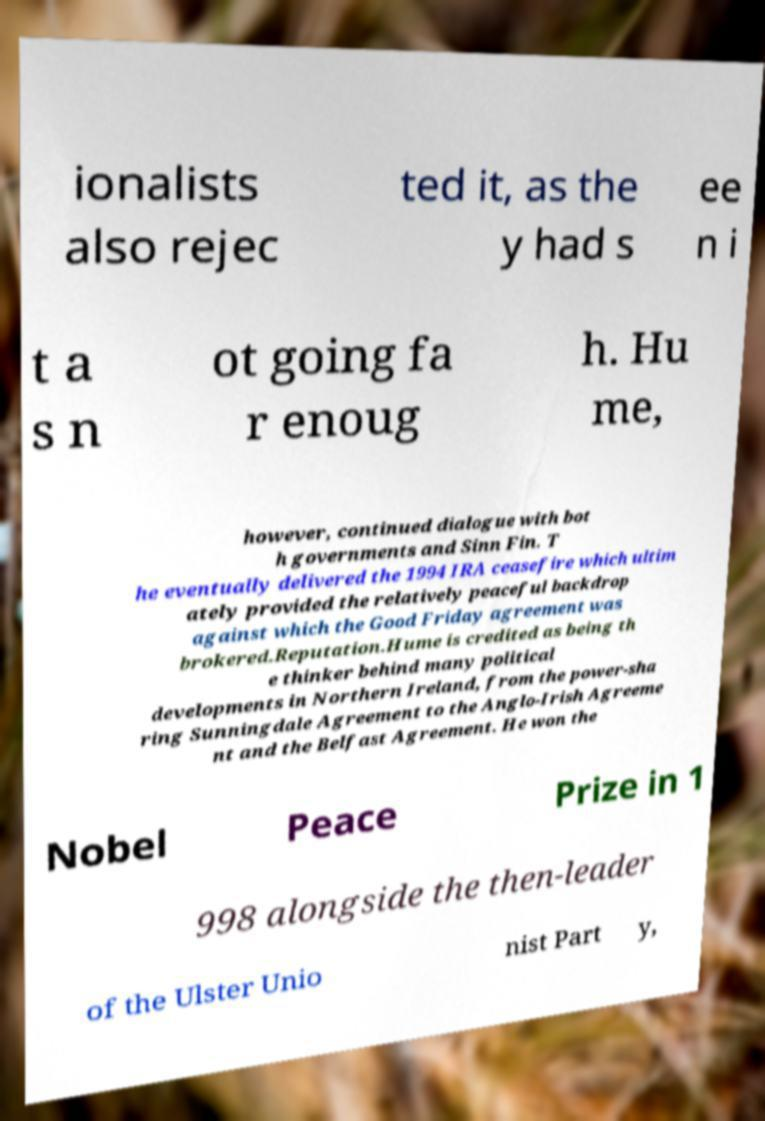Please identify and transcribe the text found in this image. ionalists also rejec ted it, as the y had s ee n i t a s n ot going fa r enoug h. Hu me, however, continued dialogue with bot h governments and Sinn Fin. T he eventually delivered the 1994 IRA ceasefire which ultim ately provided the relatively peaceful backdrop against which the Good Friday agreement was brokered.Reputation.Hume is credited as being th e thinker behind many political developments in Northern Ireland, from the power-sha ring Sunningdale Agreement to the Anglo-Irish Agreeme nt and the Belfast Agreement. He won the Nobel Peace Prize in 1 998 alongside the then-leader of the Ulster Unio nist Part y, 